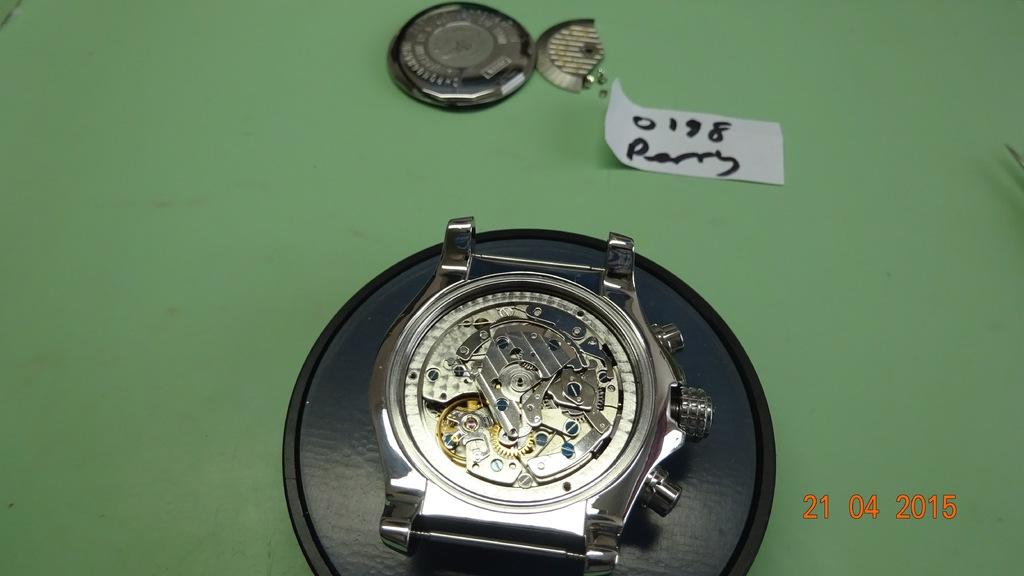What is the date on the image?
Offer a very short reply. 21 04 2015. What is the serial number on the tag?
Your answer should be compact. 0198. 